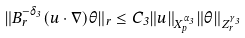<formula> <loc_0><loc_0><loc_500><loc_500>\| B ^ { - \delta _ { 3 } } _ { r } ( u \cdot \nabla ) \theta \| _ { r } \leq C _ { 3 } \| u \| _ { X ^ { \alpha _ { 3 } } _ { p } } \| \theta \| _ { Z ^ { \gamma _ { 3 } } _ { r } }</formula> 